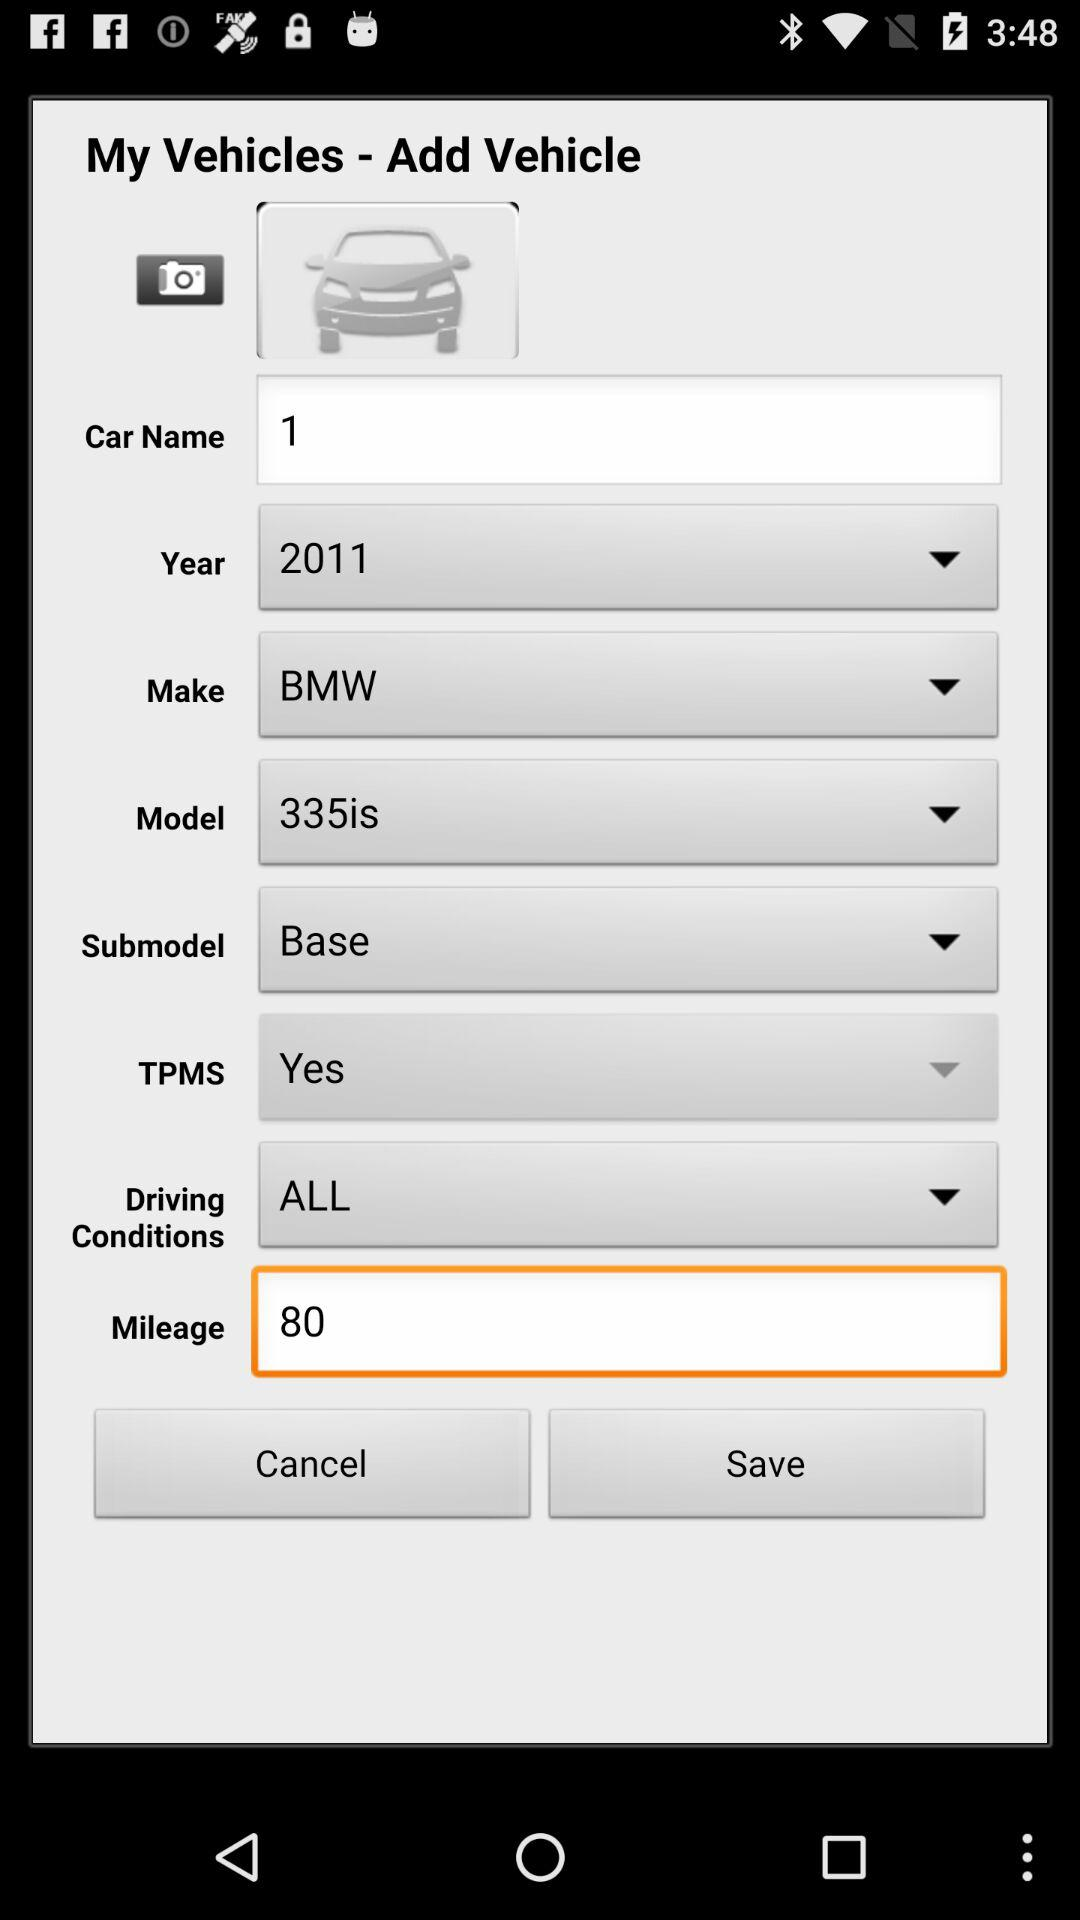What is the car name? The car name is "1". 